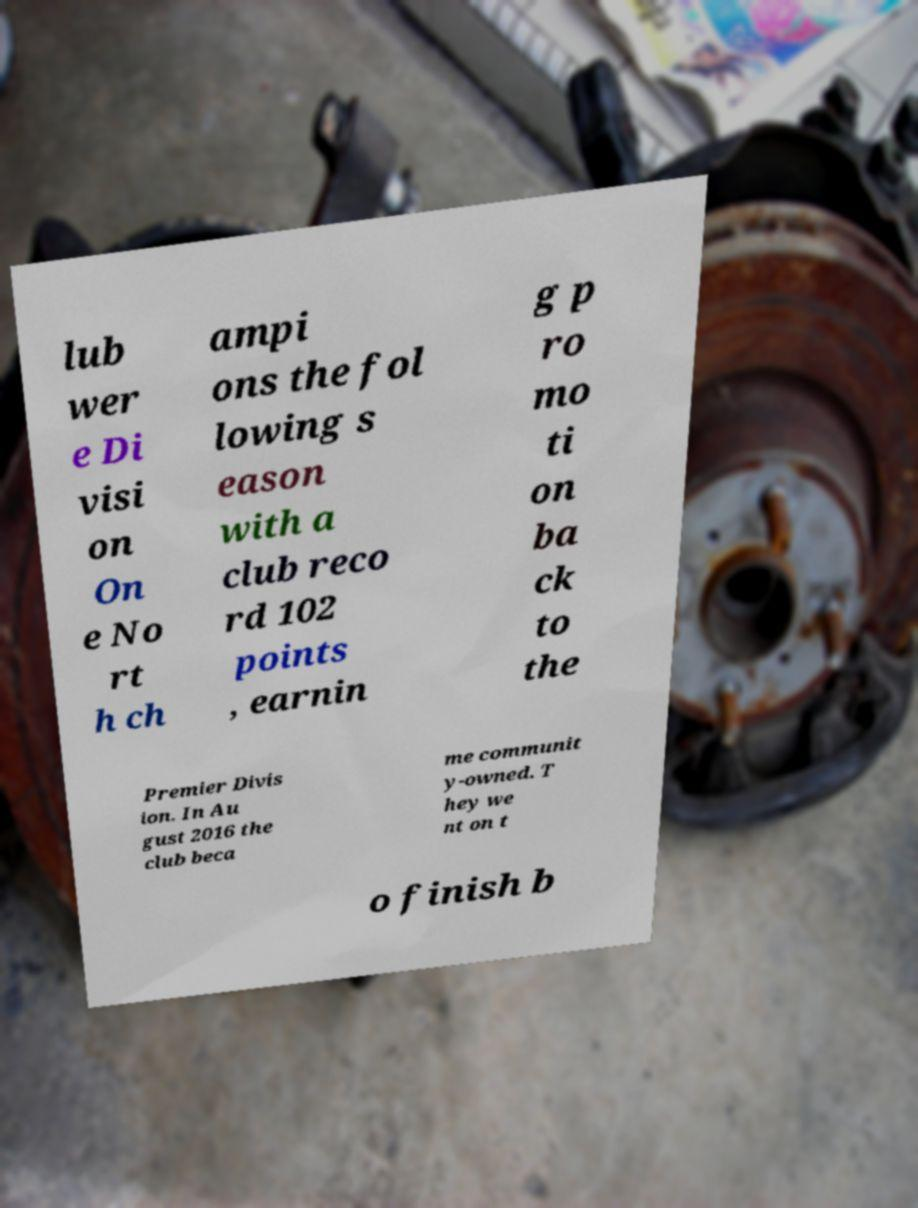For documentation purposes, I need the text within this image transcribed. Could you provide that? lub wer e Di visi on On e No rt h ch ampi ons the fol lowing s eason with a club reco rd 102 points , earnin g p ro mo ti on ba ck to the Premier Divis ion. In Au gust 2016 the club beca me communit y-owned. T hey we nt on t o finish b 